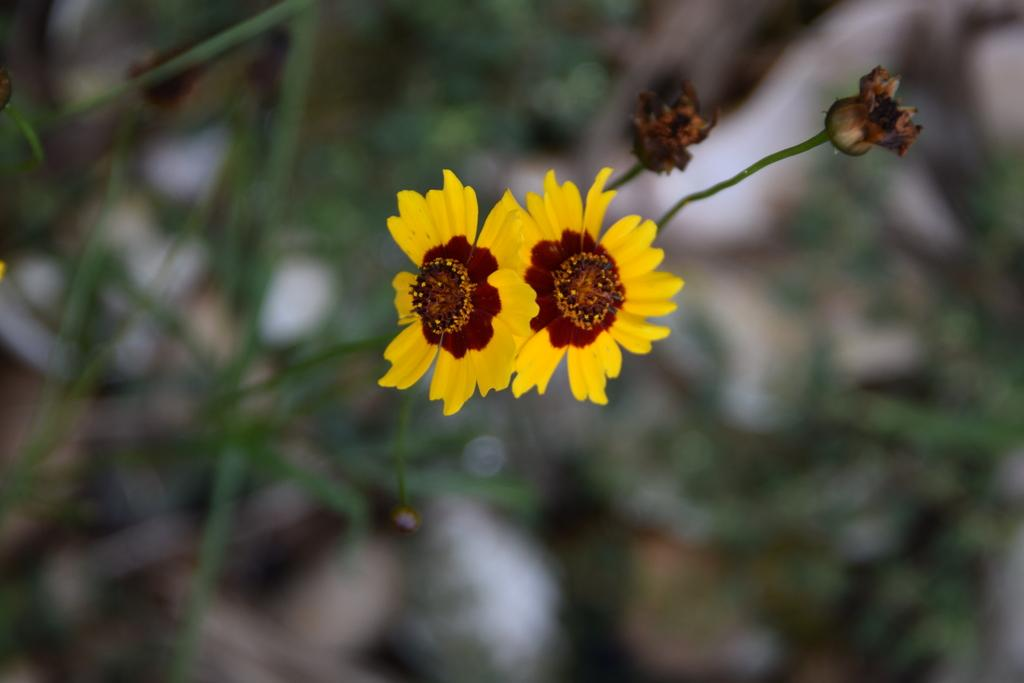What is present in the image? There are flowers in the image. Can you describe the background of the image? The background of the image is blurry. What type of lace can be seen in the image? There is no lace present in the image; it features flowers and a blurry background. 